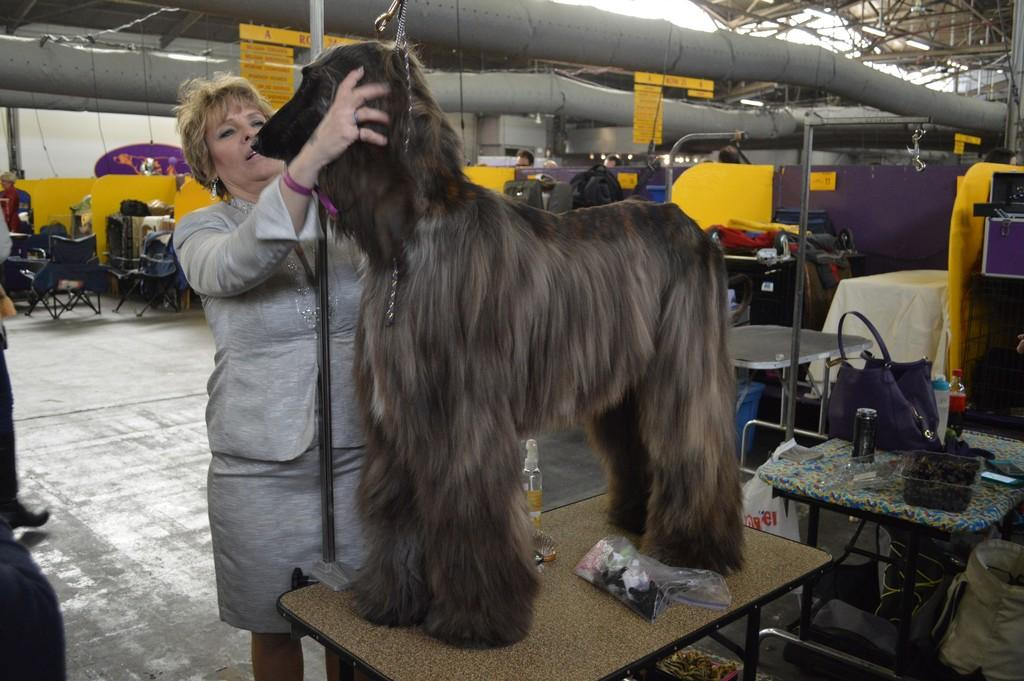What is the main subject in the image? There is a woman standing in the image. What else can be seen in the image besides the woman? There is an animal standing on a table in the image. What objects are visible in the background? There is a bag, chairs, and pipe lines in the background of the image. How does the woman control the gate in the image? There is no gate present in the image, so the woman cannot control a gate. 